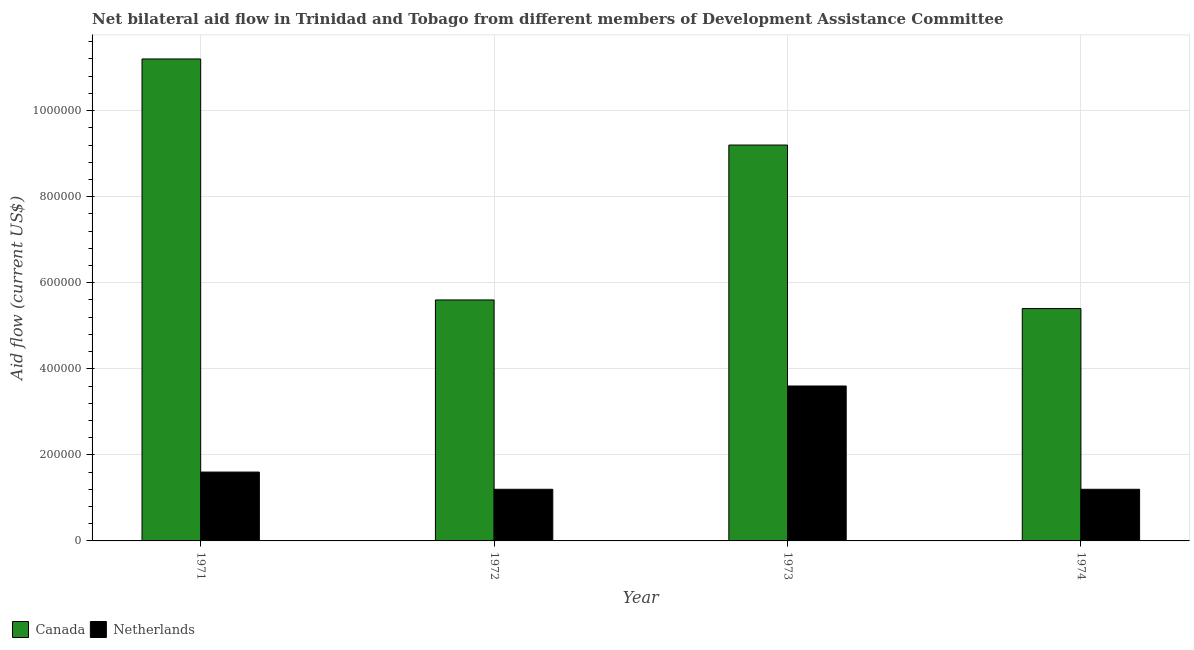Are the number of bars per tick equal to the number of legend labels?
Your answer should be compact. Yes. How many bars are there on the 1st tick from the left?
Offer a very short reply. 2. What is the label of the 3rd group of bars from the left?
Ensure brevity in your answer.  1973. What is the amount of aid given by netherlands in 1973?
Give a very brief answer. 3.60e+05. Across all years, what is the maximum amount of aid given by netherlands?
Provide a short and direct response. 3.60e+05. Across all years, what is the minimum amount of aid given by netherlands?
Offer a terse response. 1.20e+05. In which year was the amount of aid given by canada minimum?
Ensure brevity in your answer.  1974. What is the total amount of aid given by netherlands in the graph?
Make the answer very short. 7.60e+05. What is the difference between the amount of aid given by canada in 1973 and that in 1974?
Keep it short and to the point. 3.80e+05. What is the difference between the amount of aid given by canada in 1974 and the amount of aid given by netherlands in 1972?
Provide a succinct answer. -2.00e+04. What is the ratio of the amount of aid given by canada in 1972 to that in 1973?
Your answer should be compact. 0.61. What is the difference between the highest and the second highest amount of aid given by canada?
Offer a very short reply. 2.00e+05. What is the difference between the highest and the lowest amount of aid given by netherlands?
Ensure brevity in your answer.  2.40e+05. Is the sum of the amount of aid given by canada in 1971 and 1974 greater than the maximum amount of aid given by netherlands across all years?
Your answer should be very brief. Yes. What does the 1st bar from the left in 1973 represents?
Offer a terse response. Canada. Are all the bars in the graph horizontal?
Provide a succinct answer. No. What is the difference between two consecutive major ticks on the Y-axis?
Offer a very short reply. 2.00e+05. Does the graph contain any zero values?
Give a very brief answer. No. Does the graph contain grids?
Provide a short and direct response. Yes. How many legend labels are there?
Ensure brevity in your answer.  2. What is the title of the graph?
Keep it short and to the point. Net bilateral aid flow in Trinidad and Tobago from different members of Development Assistance Committee. Does "Taxes on profits and capital gains" appear as one of the legend labels in the graph?
Offer a terse response. No. What is the label or title of the Y-axis?
Make the answer very short. Aid flow (current US$). What is the Aid flow (current US$) in Canada in 1971?
Your answer should be compact. 1.12e+06. What is the Aid flow (current US$) in Canada in 1972?
Your response must be concise. 5.60e+05. What is the Aid flow (current US$) in Canada in 1973?
Make the answer very short. 9.20e+05. What is the Aid flow (current US$) in Netherlands in 1973?
Offer a terse response. 3.60e+05. What is the Aid flow (current US$) in Canada in 1974?
Your answer should be very brief. 5.40e+05. What is the Aid flow (current US$) of Netherlands in 1974?
Offer a very short reply. 1.20e+05. Across all years, what is the maximum Aid flow (current US$) in Canada?
Keep it short and to the point. 1.12e+06. Across all years, what is the minimum Aid flow (current US$) of Canada?
Make the answer very short. 5.40e+05. What is the total Aid flow (current US$) of Canada in the graph?
Your answer should be compact. 3.14e+06. What is the total Aid flow (current US$) in Netherlands in the graph?
Ensure brevity in your answer.  7.60e+05. What is the difference between the Aid flow (current US$) in Canada in 1971 and that in 1972?
Your answer should be compact. 5.60e+05. What is the difference between the Aid flow (current US$) in Canada in 1971 and that in 1974?
Provide a succinct answer. 5.80e+05. What is the difference between the Aid flow (current US$) in Netherlands in 1971 and that in 1974?
Keep it short and to the point. 4.00e+04. What is the difference between the Aid flow (current US$) in Canada in 1972 and that in 1973?
Your response must be concise. -3.60e+05. What is the difference between the Aid flow (current US$) of Canada in 1973 and that in 1974?
Keep it short and to the point. 3.80e+05. What is the difference between the Aid flow (current US$) of Canada in 1971 and the Aid flow (current US$) of Netherlands in 1972?
Your answer should be compact. 1.00e+06. What is the difference between the Aid flow (current US$) in Canada in 1971 and the Aid flow (current US$) in Netherlands in 1973?
Your answer should be very brief. 7.60e+05. What is the difference between the Aid flow (current US$) of Canada in 1972 and the Aid flow (current US$) of Netherlands in 1973?
Your answer should be compact. 2.00e+05. What is the average Aid flow (current US$) in Canada per year?
Give a very brief answer. 7.85e+05. What is the average Aid flow (current US$) in Netherlands per year?
Ensure brevity in your answer.  1.90e+05. In the year 1971, what is the difference between the Aid flow (current US$) of Canada and Aid flow (current US$) of Netherlands?
Provide a short and direct response. 9.60e+05. In the year 1973, what is the difference between the Aid flow (current US$) in Canada and Aid flow (current US$) in Netherlands?
Make the answer very short. 5.60e+05. What is the ratio of the Aid flow (current US$) in Canada in 1971 to that in 1972?
Your answer should be compact. 2. What is the ratio of the Aid flow (current US$) of Netherlands in 1971 to that in 1972?
Provide a short and direct response. 1.33. What is the ratio of the Aid flow (current US$) in Canada in 1971 to that in 1973?
Make the answer very short. 1.22. What is the ratio of the Aid flow (current US$) in Netherlands in 1971 to that in 1973?
Offer a terse response. 0.44. What is the ratio of the Aid flow (current US$) of Canada in 1971 to that in 1974?
Give a very brief answer. 2.07. What is the ratio of the Aid flow (current US$) in Canada in 1972 to that in 1973?
Your answer should be very brief. 0.61. What is the ratio of the Aid flow (current US$) of Netherlands in 1972 to that in 1974?
Make the answer very short. 1. What is the ratio of the Aid flow (current US$) of Canada in 1973 to that in 1974?
Offer a terse response. 1.7. What is the ratio of the Aid flow (current US$) of Netherlands in 1973 to that in 1974?
Your answer should be very brief. 3. What is the difference between the highest and the second highest Aid flow (current US$) in Canada?
Keep it short and to the point. 2.00e+05. What is the difference between the highest and the lowest Aid flow (current US$) of Canada?
Your response must be concise. 5.80e+05. What is the difference between the highest and the lowest Aid flow (current US$) in Netherlands?
Offer a terse response. 2.40e+05. 